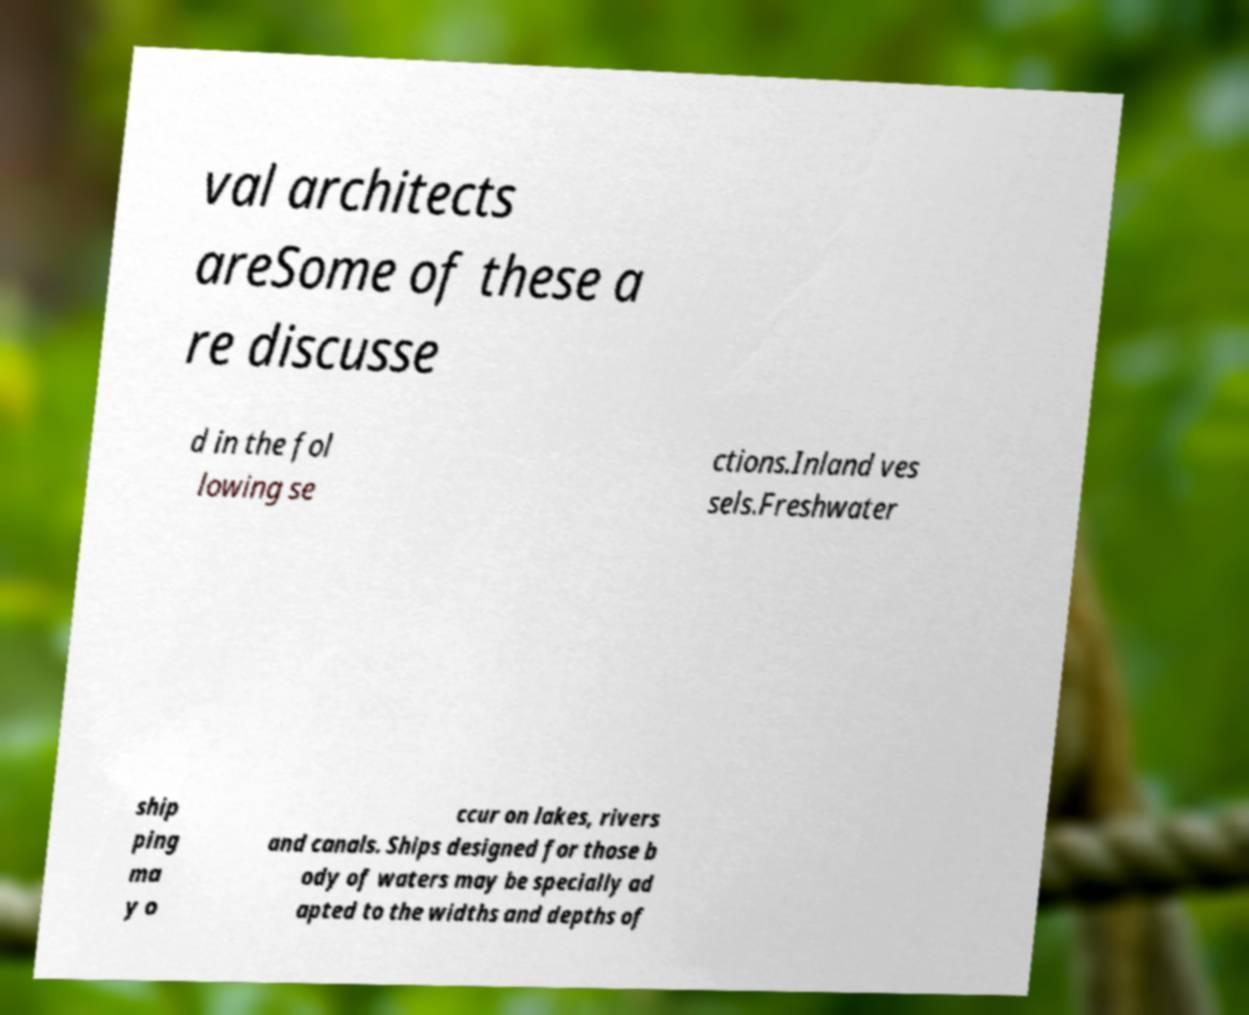I need the written content from this picture converted into text. Can you do that? val architects areSome of these a re discusse d in the fol lowing se ctions.Inland ves sels.Freshwater ship ping ma y o ccur on lakes, rivers and canals. Ships designed for those b ody of waters may be specially ad apted to the widths and depths of 